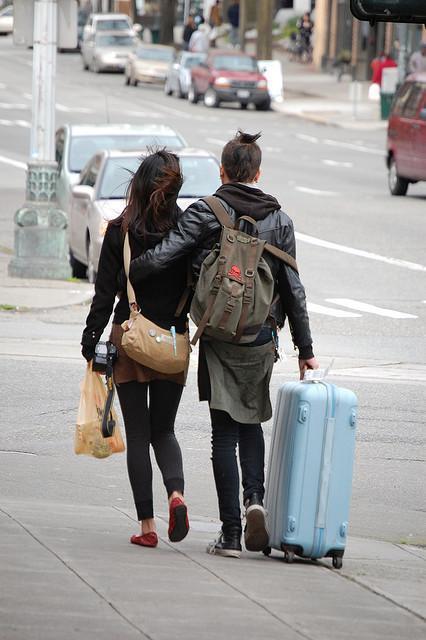How many people can you see?
Give a very brief answer. 2. How many cars are in the photo?
Give a very brief answer. 3. 